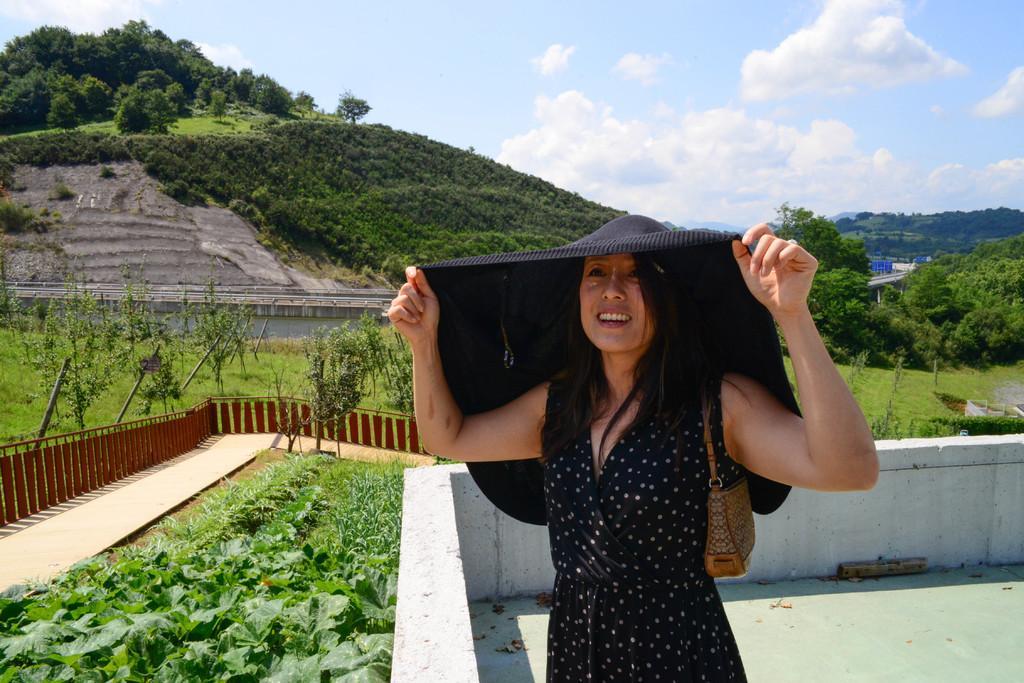In one or two sentences, can you explain what this image depicts? In the picture we can see a woman standing with a black dress and holding some black cloth from her head and besides her we can see some plants in the path and railing and near to it, we can see a hill with some part is rock surface and some part is greenery and in the background also we can see some trees and sky with clouds. 